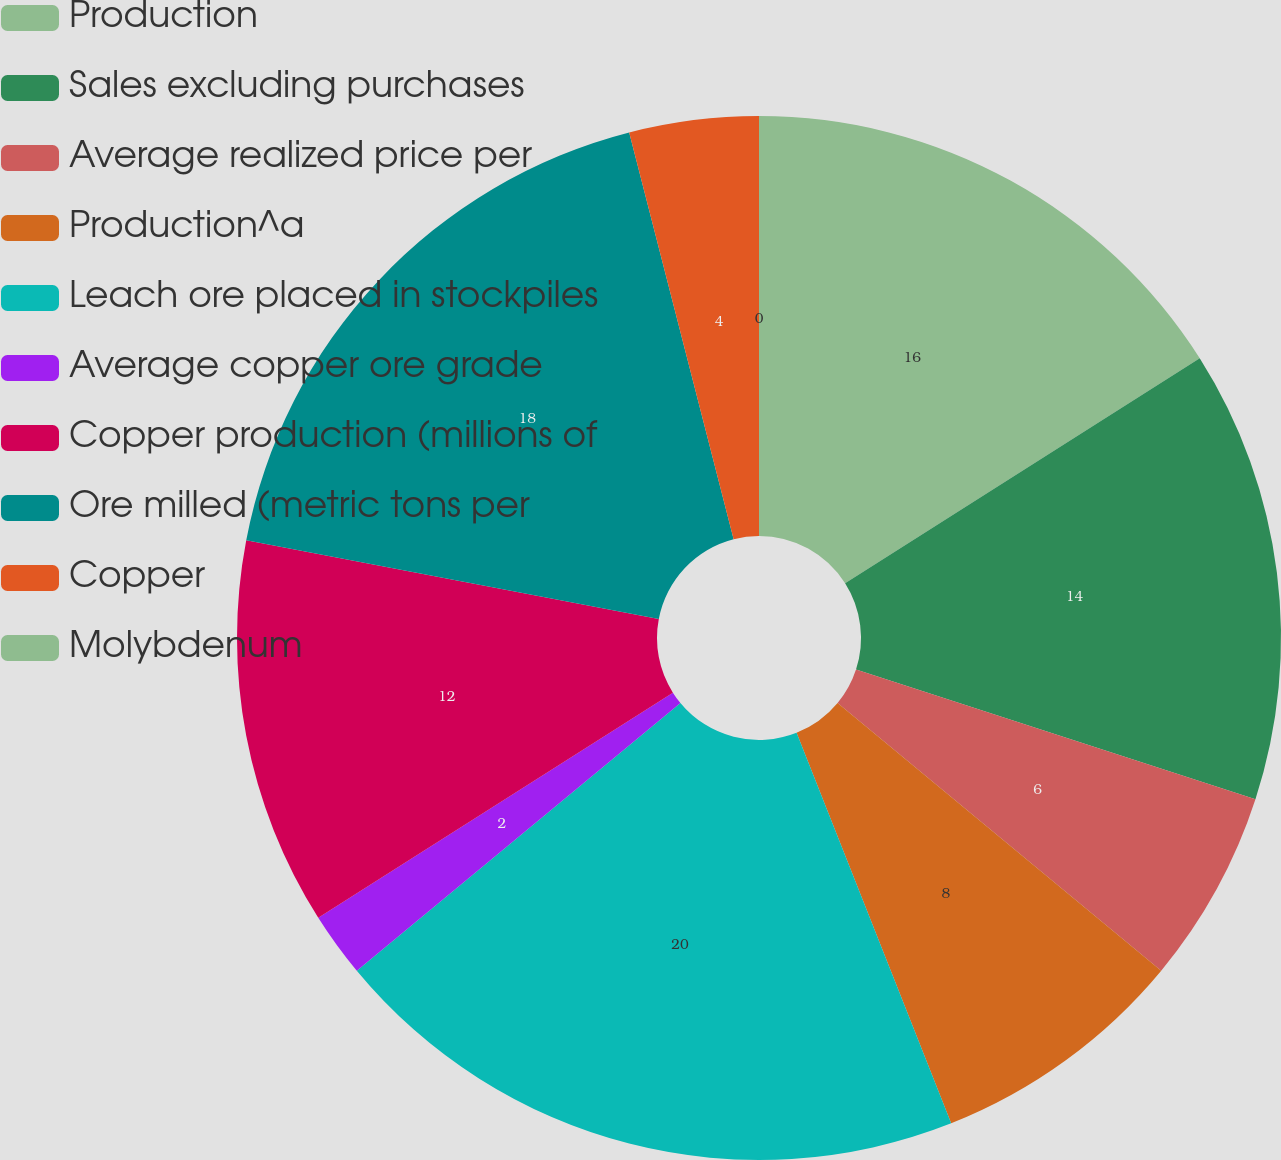Convert chart. <chart><loc_0><loc_0><loc_500><loc_500><pie_chart><fcel>Production<fcel>Sales excluding purchases<fcel>Average realized price per<fcel>Production^a<fcel>Leach ore placed in stockpiles<fcel>Average copper ore grade<fcel>Copper production (millions of<fcel>Ore milled (metric tons per<fcel>Copper<fcel>Molybdenum<nl><fcel>16.0%<fcel>14.0%<fcel>6.0%<fcel>8.0%<fcel>20.0%<fcel>2.0%<fcel>12.0%<fcel>18.0%<fcel>4.0%<fcel>0.0%<nl></chart> 